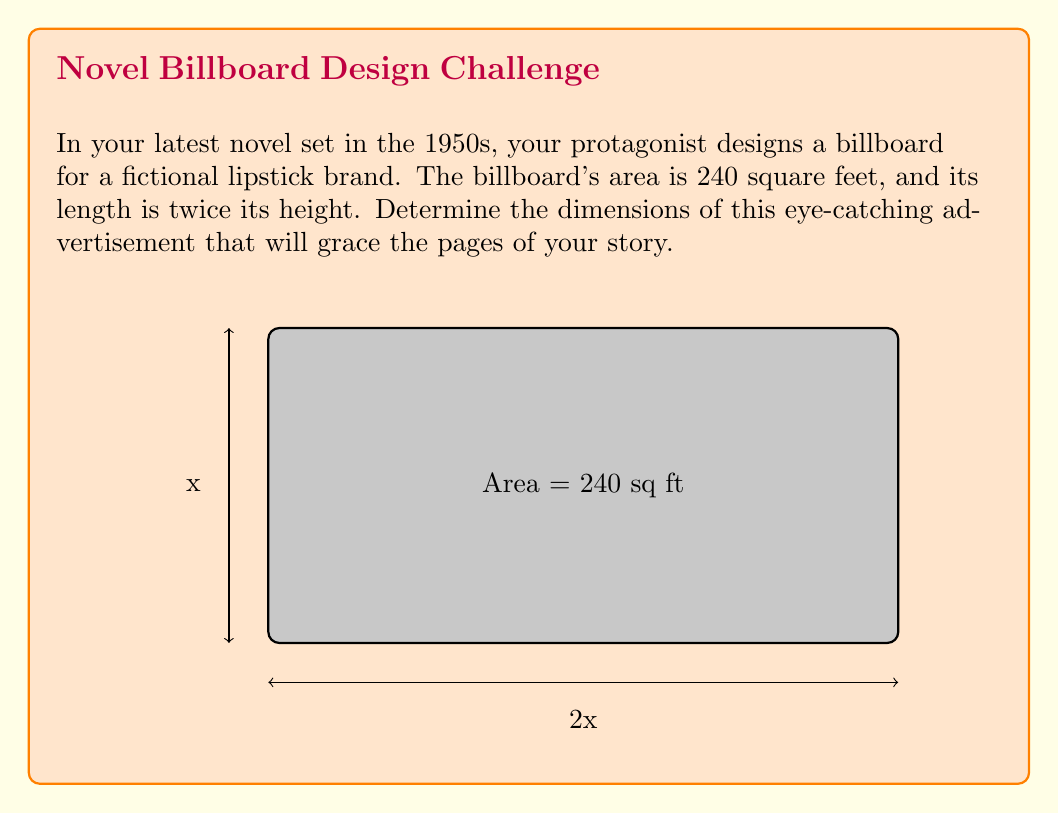Help me with this question. Let's approach this step-by-step:

1) Let the height of the billboard be $x$ feet. Since the length is twice the height, the length is $2x$ feet.

2) We know that the area of a rectangle is given by length × width. So we can write:

   $$ \text{Area} = \text{length} \times \text{width} $$
   $$ 240 = 2x \times x $$

3) Simplify the equation:

   $$ 240 = 2x^2 $$

4) Divide both sides by 2:

   $$ 120 = x^2 $$

5) Take the square root of both sides:

   $$ \sqrt{120} = x $$
   $$ x = \sqrt{120} = 4\sqrt{30} \approx 10.95 $$

6) Since $x$ represents the height, the height is approximately 10.95 feet.

7) The length is twice the height, so it's approximately 21.91 feet.

8) We can round these to the nearest inch for practicality:
   Height: 10 feet 11 inches
   Length: 21 feet 11 inches
Answer: Height: 10'11", Length: 21'11" 